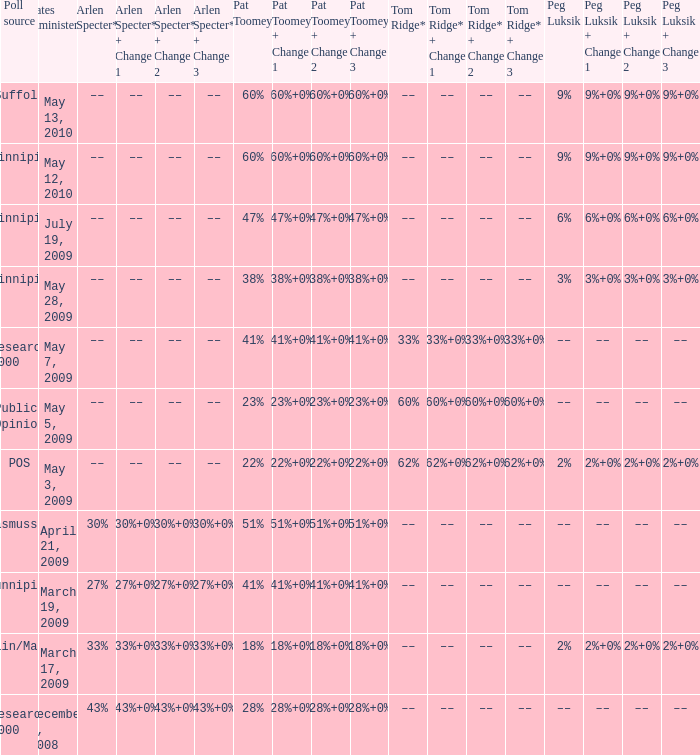Could you parse the entire table? {'header': ['Poll source', 'Dates administered', 'Arlen Specter*', 'Arlen Specter* + Change 1', 'Arlen Specter* + Change 2', 'Arlen Specter* + Change 3', 'Pat Toomey', 'Pat Toomey + Change 1', 'Pat Toomey + Change 2', 'Pat Toomey + Change 3', 'Tom Ridge*', 'Tom Ridge* + Change 1', 'Tom Ridge* + Change 2', 'Tom Ridge* + Change 3', 'Peg Luksik', 'Peg Luksik + Change 1', 'Peg Luksik + Change 2', 'Peg Luksik + Change 3'], 'rows': [['Suffolk', 'May 13, 2010', '––', '––', '––', '––', '60%', '60%+0%', '60%+0%', '60%+0%', '––', '––', '––', '––', '9%', '9%+0%', '9%+0%', '9%+0%'], ['Quinnipiac', 'May 12, 2010', '––', '––', '––', '––', '60%', '60%+0%', '60%+0%', '60%+0%', '––', '––', '––', '––', '9%', '9%+0%', '9%+0%', '9%+0%'], ['Quinnipiac', 'July 19, 2009', '––', '––', '––', '––', '47%', '47%+0%', '47%+0%', '47%+0%', '––', '––', '––', '––', '6%', '6%+0%', '6%+0%', '6%+0%'], ['Quinnipiac', 'May 28, 2009', '––', '––', '––', '––', '38%', '38%+0%', '38%+0%', '38%+0%', '––', '––', '––', '––', '3%', '3%+0%', '3%+0%', '3%+0%'], ['Research 2000', 'May 7, 2009', '––', '––', '––', '––', '41%', '41%+0%', '41%+0%', '41%+0%', '33%', '33%+0%', '33%+0%', '33%+0%', '––', '––', '––', '––'], ['Public Opinion', 'May 5, 2009', '––', '––', '––', '––', '23%', '23%+0%', '23%+0%', '23%+0%', '60%', '60%+0%', '60%+0%', '60%+0%', '––', '––', '––', '––'], ['POS', 'May 3, 2009', '––', '––', '––', '––', '22%', '22%+0%', '22%+0%', '22%+0%', '62%', '62%+0%', '62%+0%', '62%+0%', '2%', '2%+0%', '2%+0%', '2%+0%'], ['Rasmussen', 'April 21, 2009', '30%', '30%+0%', '30%+0%', '30%+0%', '51%', '51%+0%', '51%+0%', '51%+0%', '––', '––', '––', '––', '––', '––', '––', '––'], ['Qunnipiac', 'March 19, 2009', '27%', '27%+0%', '27%+0%', '27%+0%', '41%', '41%+0%', '41%+0%', '41%+0%', '––', '––', '––', '––', '––', '––', '––', '––'], ['Franklin/Marshall', 'March 17, 2009', '33%', '33%+0%', '33%+0%', '33%+0%', '18%', '18%+0%', '18%+0%', '18%+0%', '––', '––', '––', '––', '2%', '2%+0%', '2%+0%', '2%+0%'], ['Research 2000', 'December 8, 2008', '43%', '43%+0%', '43%+0%', '43%+0%', '28%', '28%+0%', '28%+0%', '28%+0%', '––', '––', '––', '––', '––', '––', '––', '––']]} Which Poll source has an Arlen Specter* of ––, and a Tom Ridge* of 60%? Public Opinion. 